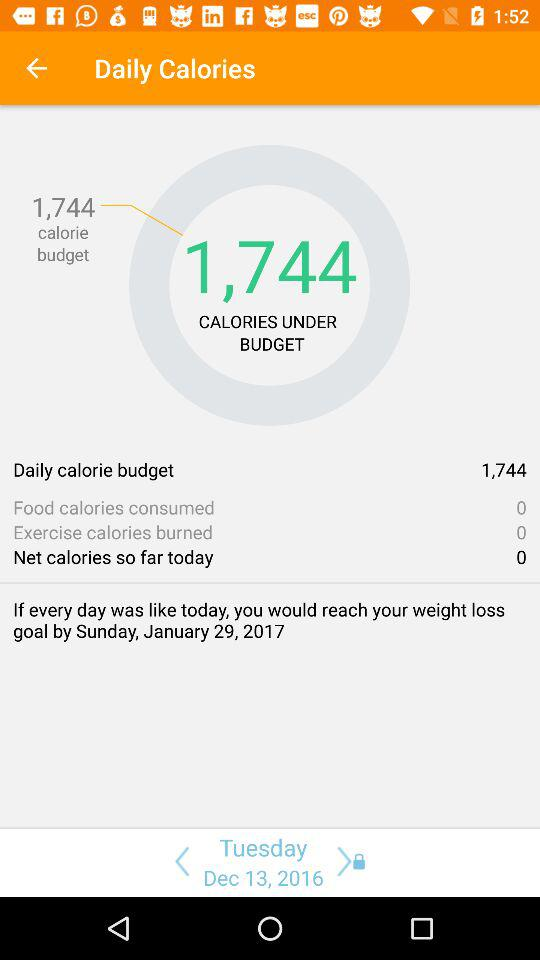What is the date? The dates are Tuesday, December 13, 2016 and Sunday, January 29, 2017. 